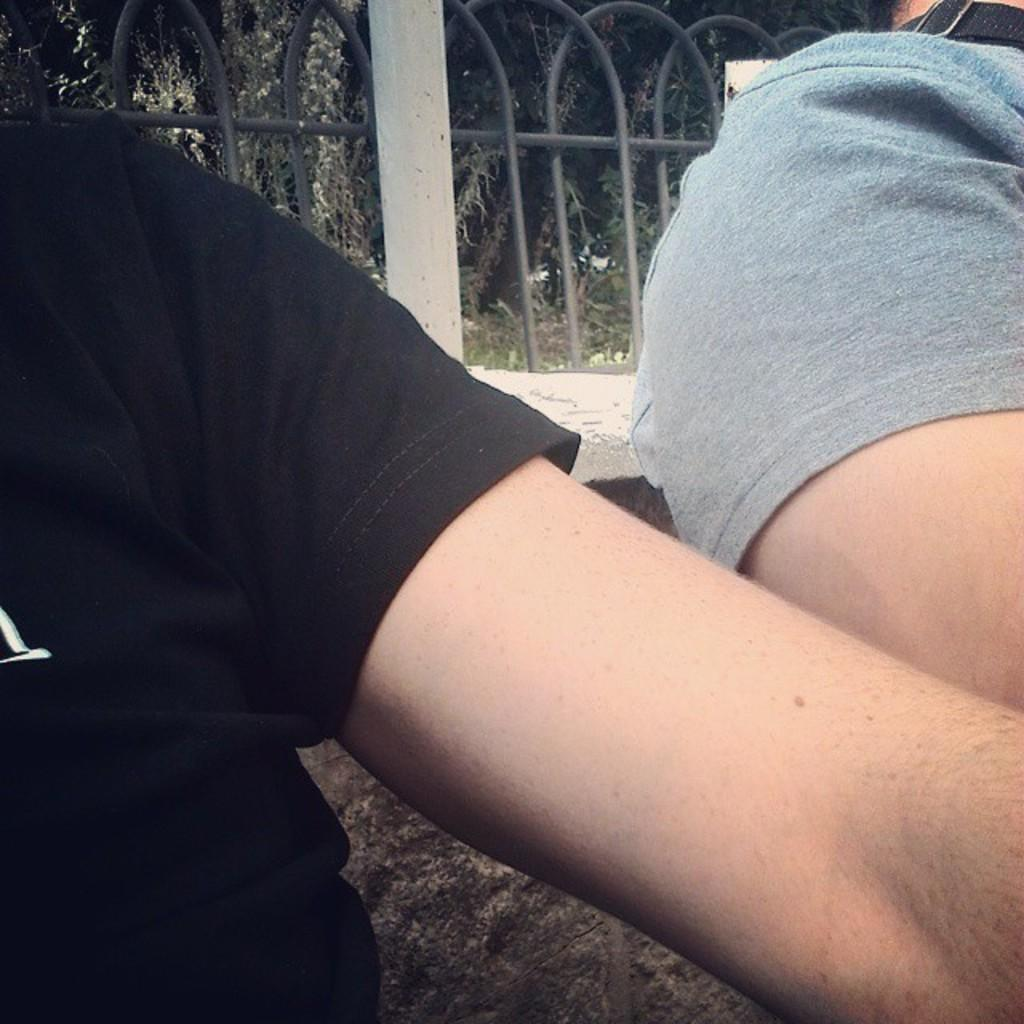How many people are present in the image? There are two persons in the image. What is the background of the image? There is a wall and trees visible in the background of the image. Are there any architectural features in the image? Yes, there is a fence in the image. What type of alley can be seen in the image? There is no alley present in the image. How many spiders are crawling on the wall in the image? There are no spiders visible in the image. 